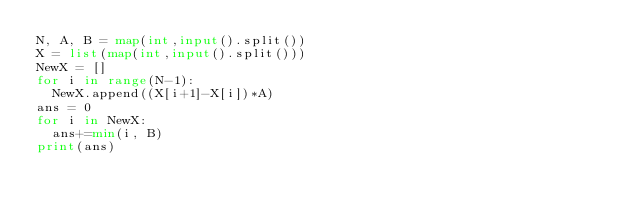<code> <loc_0><loc_0><loc_500><loc_500><_Python_>N, A, B = map(int,input().split())
X = list(map(int,input().split()))
NewX = []
for i in range(N-1):
  NewX.append((X[i+1]-X[i])*A)
ans = 0
for i in NewX:
  ans+=min(i, B)
print(ans)
  </code> 